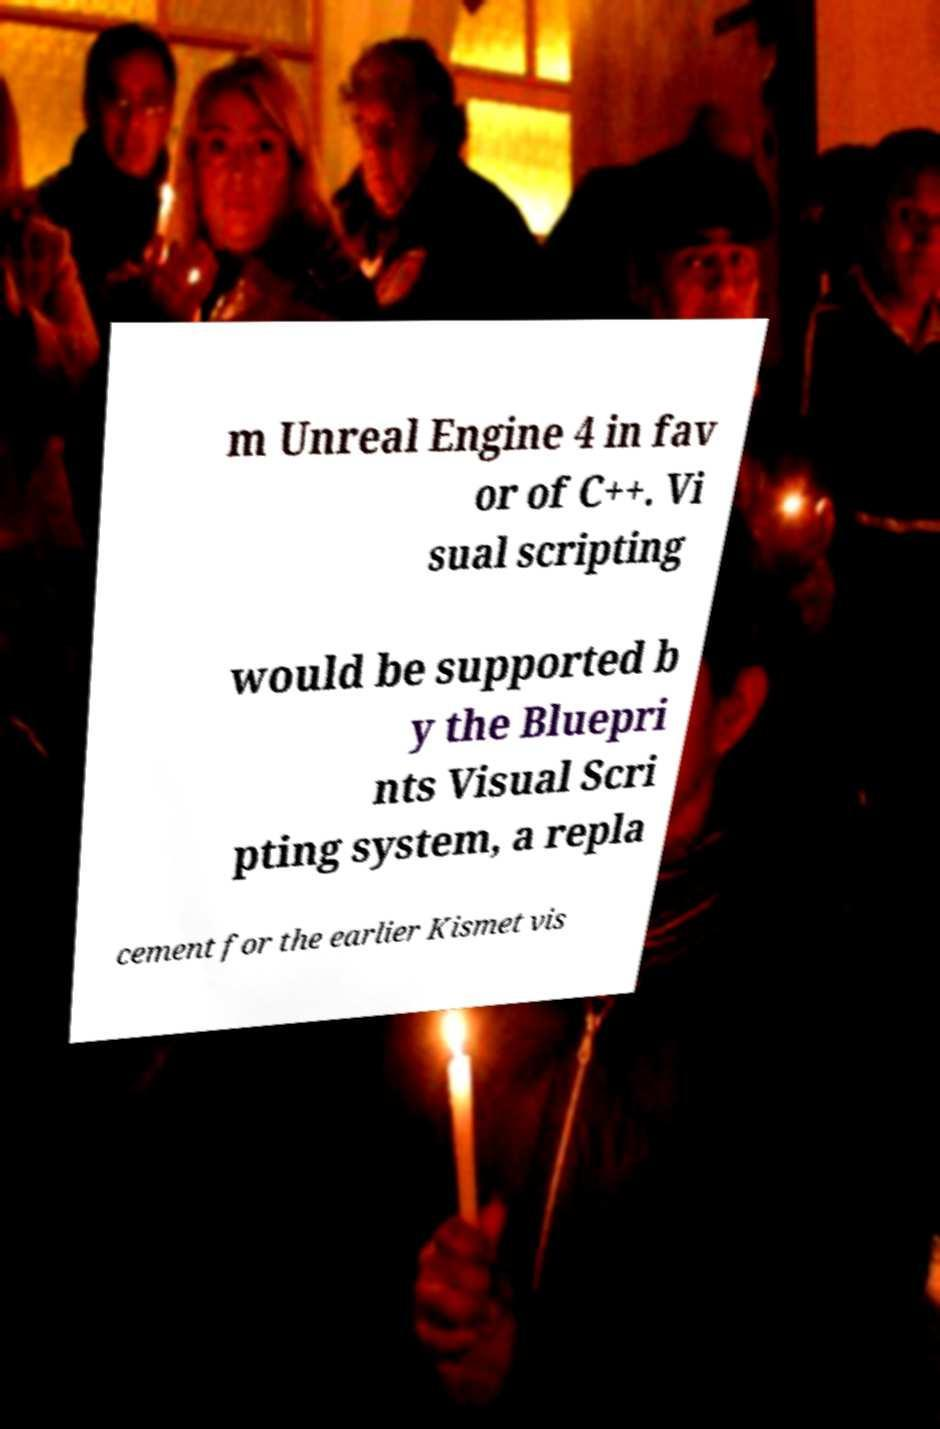For documentation purposes, I need the text within this image transcribed. Could you provide that? m Unreal Engine 4 in fav or of C++. Vi sual scripting would be supported b y the Bluepri nts Visual Scri pting system, a repla cement for the earlier Kismet vis 